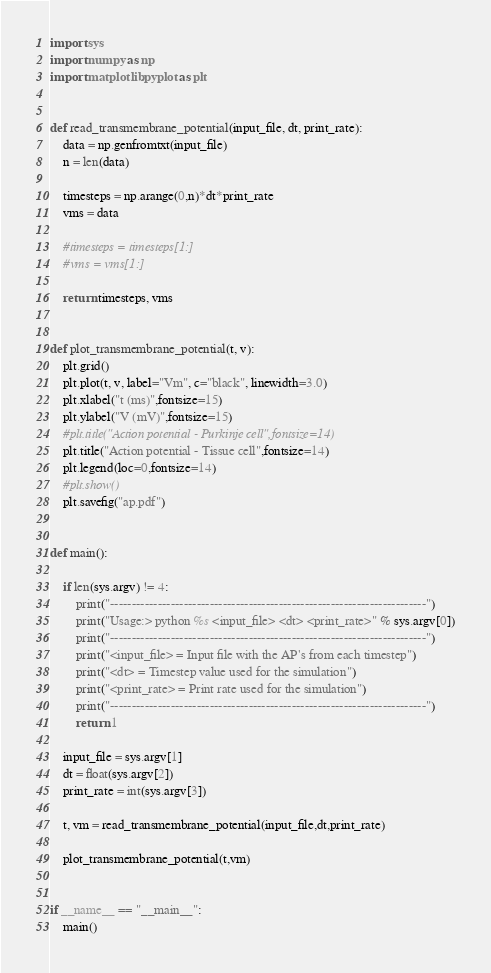<code> <loc_0><loc_0><loc_500><loc_500><_Python_>import sys
import numpy as np
import matplotlib.pyplot as plt


def read_transmembrane_potential(input_file, dt, print_rate):
	data = np.genfromtxt(input_file)
	n = len(data)

	timesteps = np.arange(0,n)*dt*print_rate
	vms = data

	#timesteps = timesteps[1:]
	#vms = vms[1:]

	return timesteps, vms


def plot_transmembrane_potential(t, v):
	plt.grid()
	plt.plot(t, v, label="Vm", c="black", linewidth=3.0)
	plt.xlabel("t (ms)",fontsize=15)
	plt.ylabel("V (mV)",fontsize=15)
	#plt.title("Action potential - Purkinje cell",fontsize=14)
	plt.title("Action potential - Tissue cell",fontsize=14)
	plt.legend(loc=0,fontsize=14)
	#plt.show()
	plt.savefig("ap.pdf")


def main():
	
	if len(sys.argv) != 4:
		print("-------------------------------------------------------------------------")
		print("Usage:> python %s <input_file> <dt> <print_rate>" % sys.argv[0])
		print("-------------------------------------------------------------------------")
		print("<input_file> = Input file with the AP's from each timestep")
		print("<dt> = Timestep value used for the simulation")
		print("<print_rate> = Print rate used for the simulation")
		print("-------------------------------------------------------------------------")
		return 1

	input_file = sys.argv[1]
	dt = float(sys.argv[2])
	print_rate = int(sys.argv[3])

	t, vm = read_transmembrane_potential(input_file,dt,print_rate)

	plot_transmembrane_potential(t,vm)


if __name__ == "__main__":
	main()
</code> 